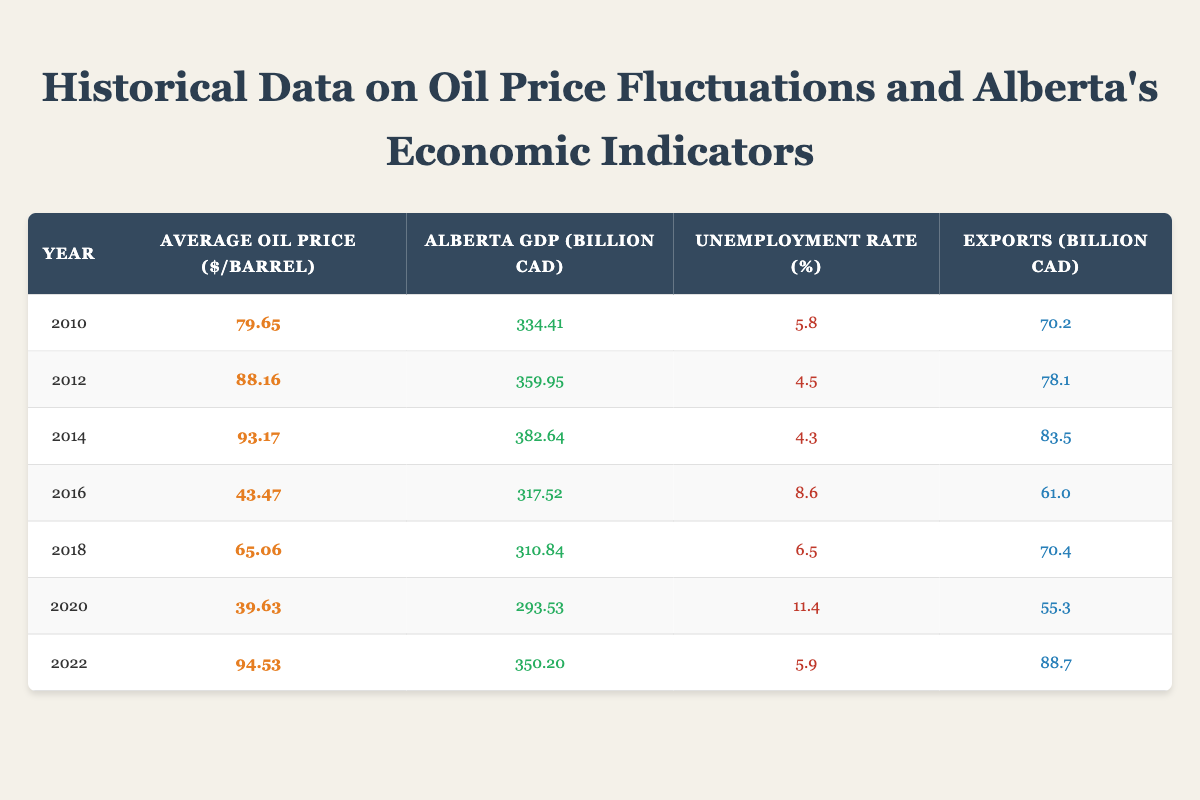What was the average oil price per barrel in 2014? The table shows that in 2014, the average price per barrel was 93.17.
Answer: 93.17 In which year did Alberta experience the highest GDP? The table indicates that Alberta's GDP peaked in 2014 at 382.64 billion CAD, which is the highest compared to other years listed.
Answer: 2014 Was the unemployment rate higher in 2020 than in 2016? To determine this, we inspect the unemployment rates: in 2020 it was 11.4%, while in 2016 it was 8.6%. Since 11.4% > 8.6%, the statement is true.
Answer: Yes What is the total export value from 2010 to 2022? To find the total exports, we sum the export values listed: 70.2 + 78.1 + 83.5 + 61.0 + 70.4 + 55.3 + 88.7 = 507.2 billion CAD.
Answer: 507.2 In which year did Alberta's unemployment rate drop below 5%? In examining the table, it is clear the only year when the unemployment rate was below 5% was in 2012, at 4.5%.
Answer: 2012 What was the average oil price between 2010 and 2022? The average price is calculated by adding the prices from each year (79.65 + 88.16 + 93.17 + 43.47 + 65.06 + 39.63 + 94.53) which totals 503.67, and then dividing this by the 7 years gives an average of 71.95.
Answer: 71.95 Did Alberta's GDP in 2022 exceed that of 2012? By comparing the values, in 2022 the GDP was 350.20 billion CAD, while in 2012 it was 359.95 billion CAD. Since 350.20 < 359.95, the statement is false.
Answer: No What trend can be observed regarding oil prices and unemployment rates from 2010 to 2022? Observing the data, as oil prices increased over several years, especially from 2012 to 2014, the unemployment rates decreased. Conversely, in years where oil prices dropped significantly, like in 2016 and 2020, unemployment rates increased. This suggests a possible correlation where low oil prices lead to higher unemployment.
Answer: Oil prices influence unemployment rates negatively 